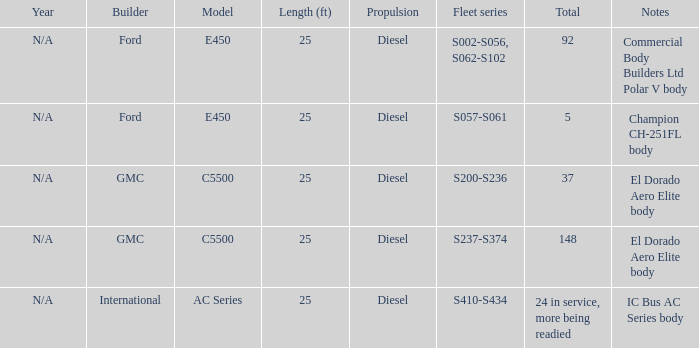When the total is 5, what are the notes associated with ford? Champion CH-251FL body. 